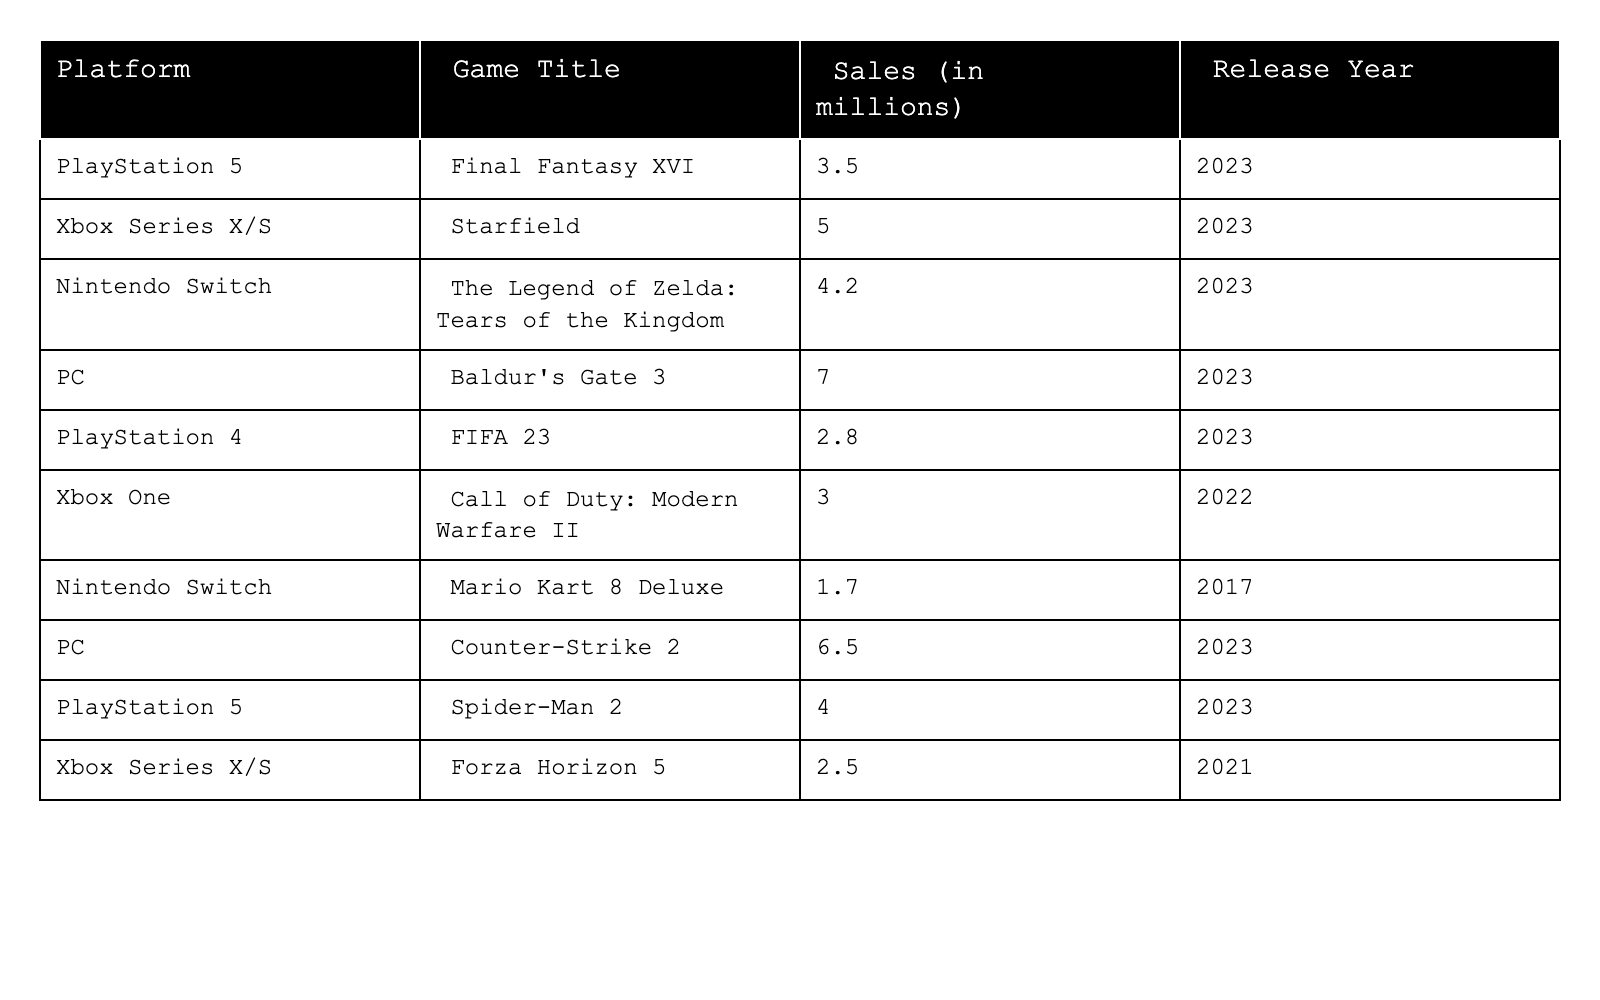What's the total sales for all games on the PlayStation 5? The sales for PlayStation 5 games in the table are Final Fantasy XVI (3.5 million) and Spider-Man 2 (4.0 million). Adding these sales gives 3.5 + 4.0 = 7.5 million.
Answer: 7.5 million Which game had the highest sales? The game with the highest sales is Baldur's Gate 3 with 7.0 million sold on PC.
Answer: Baldur's Gate 3 Did any Nintendo Switch game release in 2023? Yes, The Legend of Zelda: Tears of the Kingdom was released in 2023 with sales of 4.2 million.
Answer: Yes What's the average sales for games on Xbox Series X/S? The sales for Xbox Series X/S games are Starfield (5.0 million) and Forza Horizon 5 (2.5 million). Adding them gives 5.0 + 2.5 = 7.5 million. Dividing by 2 (the number of games) gives an average of 7.5 / 2 = 3.75 million.
Answer: 3.75 million How many games had sales above 5 million? There are two games with sales above 5 million: Baldur's Gate 3 (7.0 million) and Counter-Strike 2 (6.5 million).
Answer: 2 Is there a game from 2022 that sold more than 3 million? Yes, Call of Duty: Modern Warfare II, released in 2022, sold 3.0 million.
Answer: Yes What's the difference in sales between the highest and lowest-selling game? The highest-selling game is Baldur's Gate 3 with 7.0 million, and the lowest is FIFA 23 on PlayStation 4 with 2.8 million. The difference is 7.0 - 2.8 = 4.2 million.
Answer: 4.2 million How many total platforms are listed in the table? There are four listed platforms: PlayStation 5, Xbox Series X/S, Nintendo Switch, and PC.
Answer: 4 Which platform had the most games in the table? PlayStation 5 has two games: Final Fantasy XVI and Spider-Man 2. No platform has more than two games listed.
Answer: PlayStation 5 What is the total sales for Nintendo Switch games? Nintendo Switch games listed are The Legend of Zelda: Tears of the Kingdom (4.2 million) and Mario Kart 8 Deluxe (1.7 million). The total sales are 4.2 + 1.7 = 5.9 million.
Answer: 5.9 million 